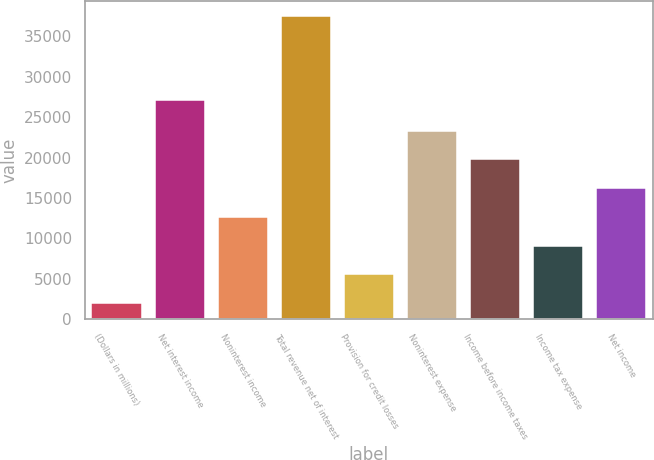Convert chart. <chart><loc_0><loc_0><loc_500><loc_500><bar_chart><fcel>(Dollars in millions)<fcel>Net interest income<fcel>Noninterest income<fcel>Total revenue net of interest<fcel>Provision for credit losses<fcel>Noninterest expense<fcel>Income before income taxes<fcel>Income tax expense<fcel>Net income<nl><fcel>2018<fcel>27123<fcel>12669.5<fcel>37523<fcel>5568.5<fcel>23321<fcel>19770.5<fcel>9119<fcel>16220<nl></chart> 